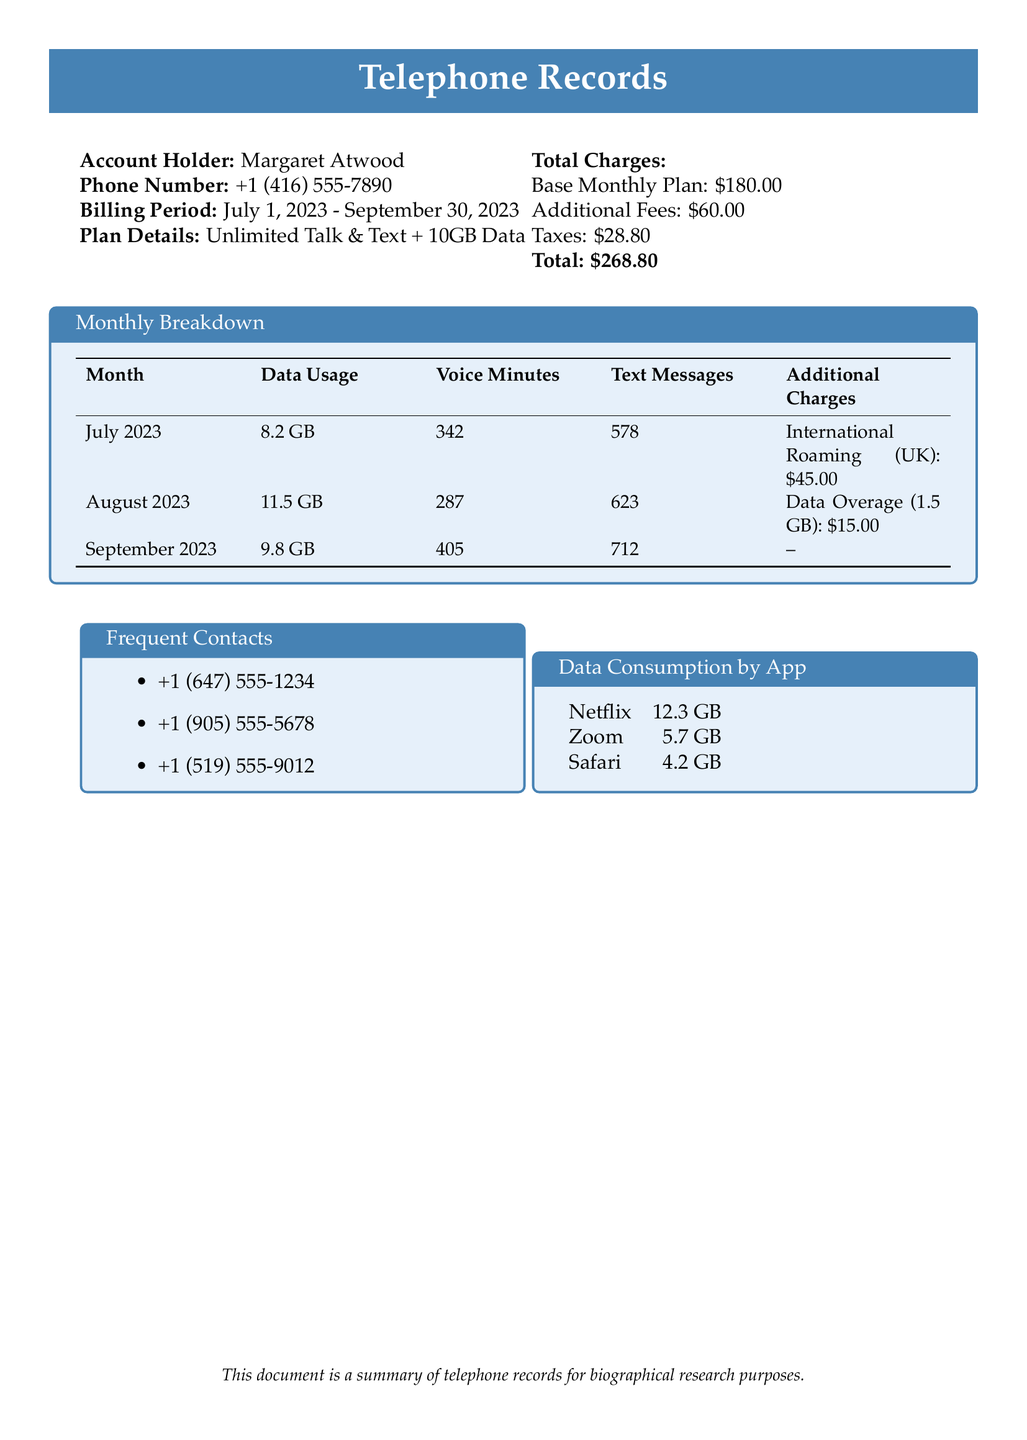What is the billing period? The billing period is specified as the duration for which the account is charged, which is from July 1, 2023 to September 30, 2023.
Answer: July 1, 2023 - September 30, 2023 Who is the account holder? The account holder's name is mentioned at the beginning of the document.
Answer: Margaret Atwood How much is the base monthly plan? The base monthly plan cost is detailed in the total charges section.
Answer: $180.00 What was the data usage in August 2023? Data usage for each month is summarized in the monthly breakdown table.
Answer: 11.5 GB What is the total amount paid including taxes? The total amount shows the sum of base monthly plan, additional fees, and taxes.
Answer: $268.80 Which app consumed the most data? Data consumption by app is presented in the app usage table.
Answer: Netflix How many voice minutes were used in July 2023? The monthly breakdown table includes specific voice minutes used for that month.
Answer: 342 What additional charge occurred in July 2023? The additional charges for each month are provided in the monthly breakdown section.
Answer: International Roaming (UK): $45.00 What is the number of text messages sent in September 2023? The number of text messages is listed in the monthly breakdown table for September 2023.
Answer: 712 